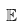Convert formula to latex. <formula><loc_0><loc_0><loc_500><loc_500>\mathbb { E }</formula> 